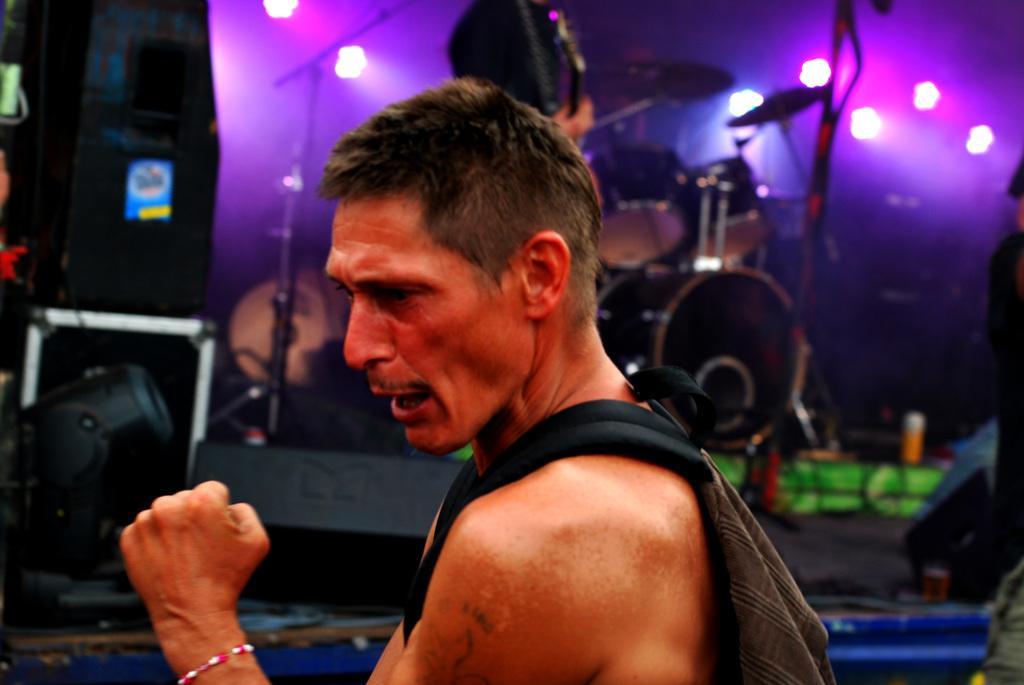Could you give a brief overview of what you see in this image? In the foreground of this picture we can see a man wearing a backpack and seems to be standing. In the background we can see the focusing lights, musical instruments, a person standing and seems to be playing guitar and we can see many other objects in the background. 